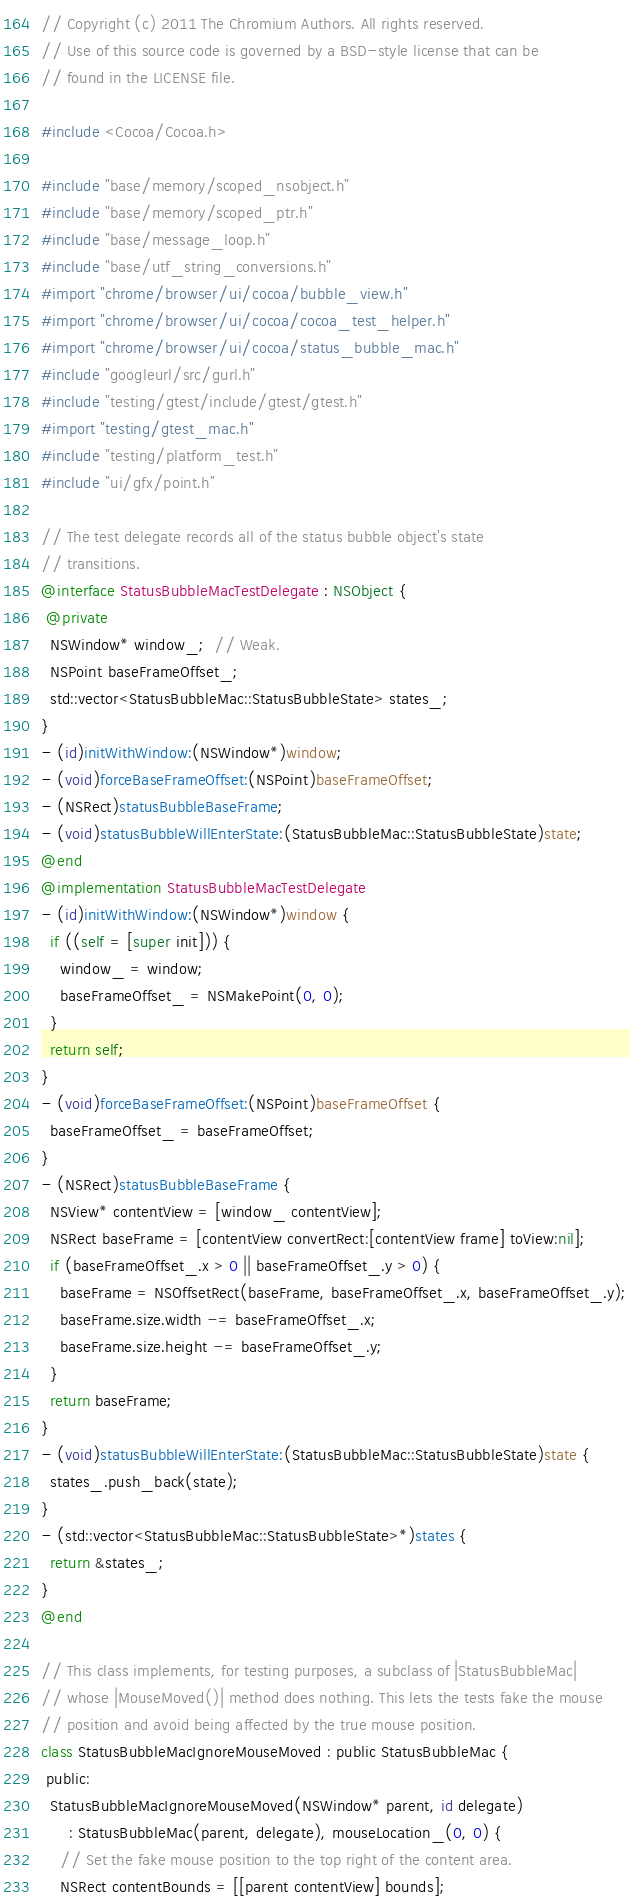Convert code to text. <code><loc_0><loc_0><loc_500><loc_500><_ObjectiveC_>// Copyright (c) 2011 The Chromium Authors. All rights reserved.
// Use of this source code is governed by a BSD-style license that can be
// found in the LICENSE file.

#include <Cocoa/Cocoa.h>

#include "base/memory/scoped_nsobject.h"
#include "base/memory/scoped_ptr.h"
#include "base/message_loop.h"
#include "base/utf_string_conversions.h"
#import "chrome/browser/ui/cocoa/bubble_view.h"
#import "chrome/browser/ui/cocoa/cocoa_test_helper.h"
#import "chrome/browser/ui/cocoa/status_bubble_mac.h"
#include "googleurl/src/gurl.h"
#include "testing/gtest/include/gtest/gtest.h"
#import "testing/gtest_mac.h"
#include "testing/platform_test.h"
#include "ui/gfx/point.h"

// The test delegate records all of the status bubble object's state
// transitions.
@interface StatusBubbleMacTestDelegate : NSObject {
 @private
  NSWindow* window_;  // Weak.
  NSPoint baseFrameOffset_;
  std::vector<StatusBubbleMac::StatusBubbleState> states_;
}
- (id)initWithWindow:(NSWindow*)window;
- (void)forceBaseFrameOffset:(NSPoint)baseFrameOffset;
- (NSRect)statusBubbleBaseFrame;
- (void)statusBubbleWillEnterState:(StatusBubbleMac::StatusBubbleState)state;
@end
@implementation StatusBubbleMacTestDelegate
- (id)initWithWindow:(NSWindow*)window {
  if ((self = [super init])) {
    window_ = window;
    baseFrameOffset_ = NSMakePoint(0, 0);
  }
  return self;
}
- (void)forceBaseFrameOffset:(NSPoint)baseFrameOffset {
  baseFrameOffset_ = baseFrameOffset;
}
- (NSRect)statusBubbleBaseFrame {
  NSView* contentView = [window_ contentView];
  NSRect baseFrame = [contentView convertRect:[contentView frame] toView:nil];
  if (baseFrameOffset_.x > 0 || baseFrameOffset_.y > 0) {
    baseFrame = NSOffsetRect(baseFrame, baseFrameOffset_.x, baseFrameOffset_.y);
    baseFrame.size.width -= baseFrameOffset_.x;
    baseFrame.size.height -= baseFrameOffset_.y;
  }
  return baseFrame;
}
- (void)statusBubbleWillEnterState:(StatusBubbleMac::StatusBubbleState)state {
  states_.push_back(state);
}
- (std::vector<StatusBubbleMac::StatusBubbleState>*)states {
  return &states_;
}
@end

// This class implements, for testing purposes, a subclass of |StatusBubbleMac|
// whose |MouseMoved()| method does nothing. This lets the tests fake the mouse
// position and avoid being affected by the true mouse position.
class StatusBubbleMacIgnoreMouseMoved : public StatusBubbleMac {
 public:
  StatusBubbleMacIgnoreMouseMoved(NSWindow* parent, id delegate)
      : StatusBubbleMac(parent, delegate), mouseLocation_(0, 0) {
    // Set the fake mouse position to the top right of the content area.
    NSRect contentBounds = [[parent contentView] bounds];</code> 